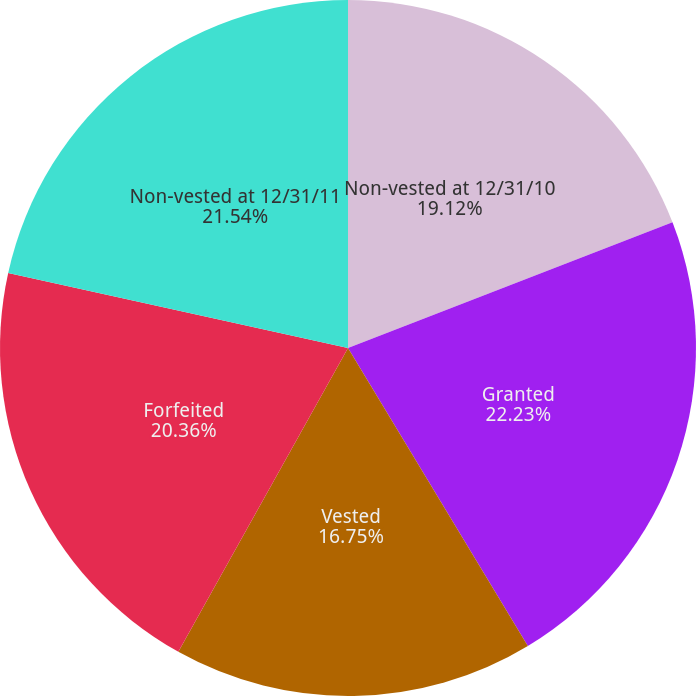Convert chart. <chart><loc_0><loc_0><loc_500><loc_500><pie_chart><fcel>Non-vested at 12/31/10<fcel>Granted<fcel>Vested<fcel>Forfeited<fcel>Non-vested at 12/31/11<nl><fcel>19.12%<fcel>22.24%<fcel>16.75%<fcel>20.36%<fcel>21.54%<nl></chart> 